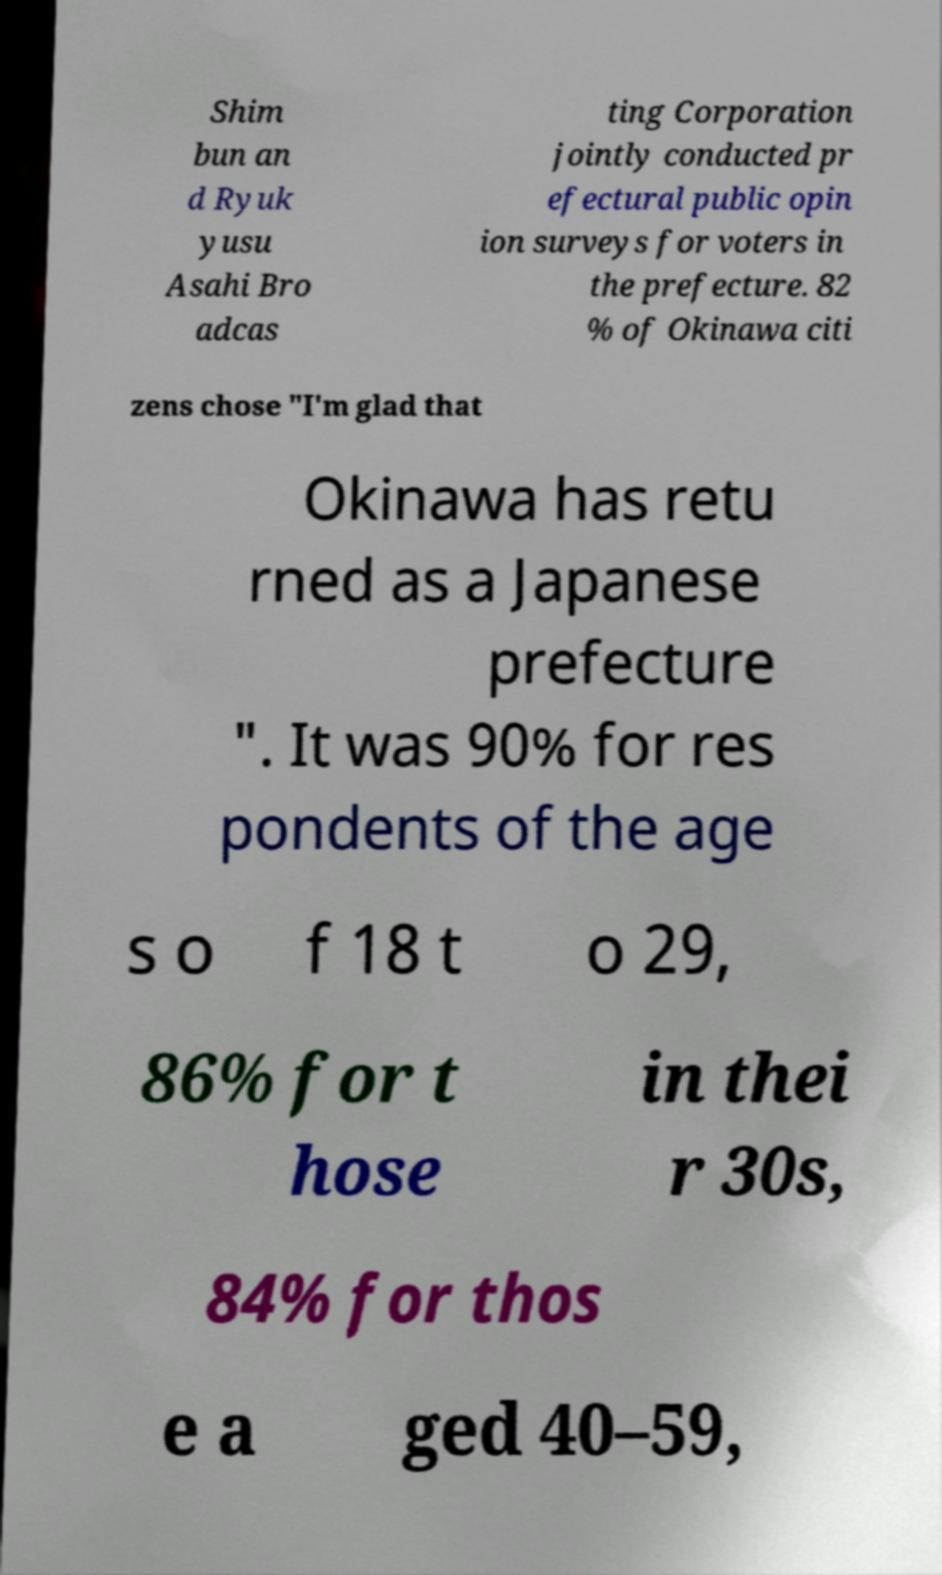I need the written content from this picture converted into text. Can you do that? Shim bun an d Ryuk yusu Asahi Bro adcas ting Corporation jointly conducted pr efectural public opin ion surveys for voters in the prefecture. 82 % of Okinawa citi zens chose "I'm glad that Okinawa has retu rned as a Japanese prefecture ". It was 90% for res pondents of the age s o f 18 t o 29, 86% for t hose in thei r 30s, 84% for thos e a ged 40–59, 